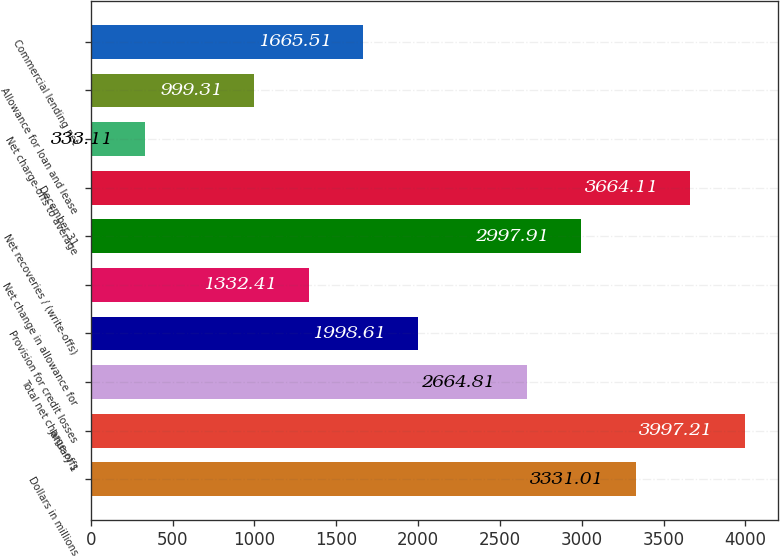Convert chart to OTSL. <chart><loc_0><loc_0><loc_500><loc_500><bar_chart><fcel>Dollars in millions<fcel>January 1<fcel>Total net charge-offs<fcel>Provision for credit losses<fcel>Net change in allowance for<fcel>Net recoveries / (write-offs)<fcel>December 31<fcel>Net charge-offs to average<fcel>Allowance for loan and lease<fcel>Commercial lending net<nl><fcel>3331.01<fcel>3997.21<fcel>2664.81<fcel>1998.61<fcel>1332.41<fcel>2997.91<fcel>3664.11<fcel>333.11<fcel>999.31<fcel>1665.51<nl></chart> 